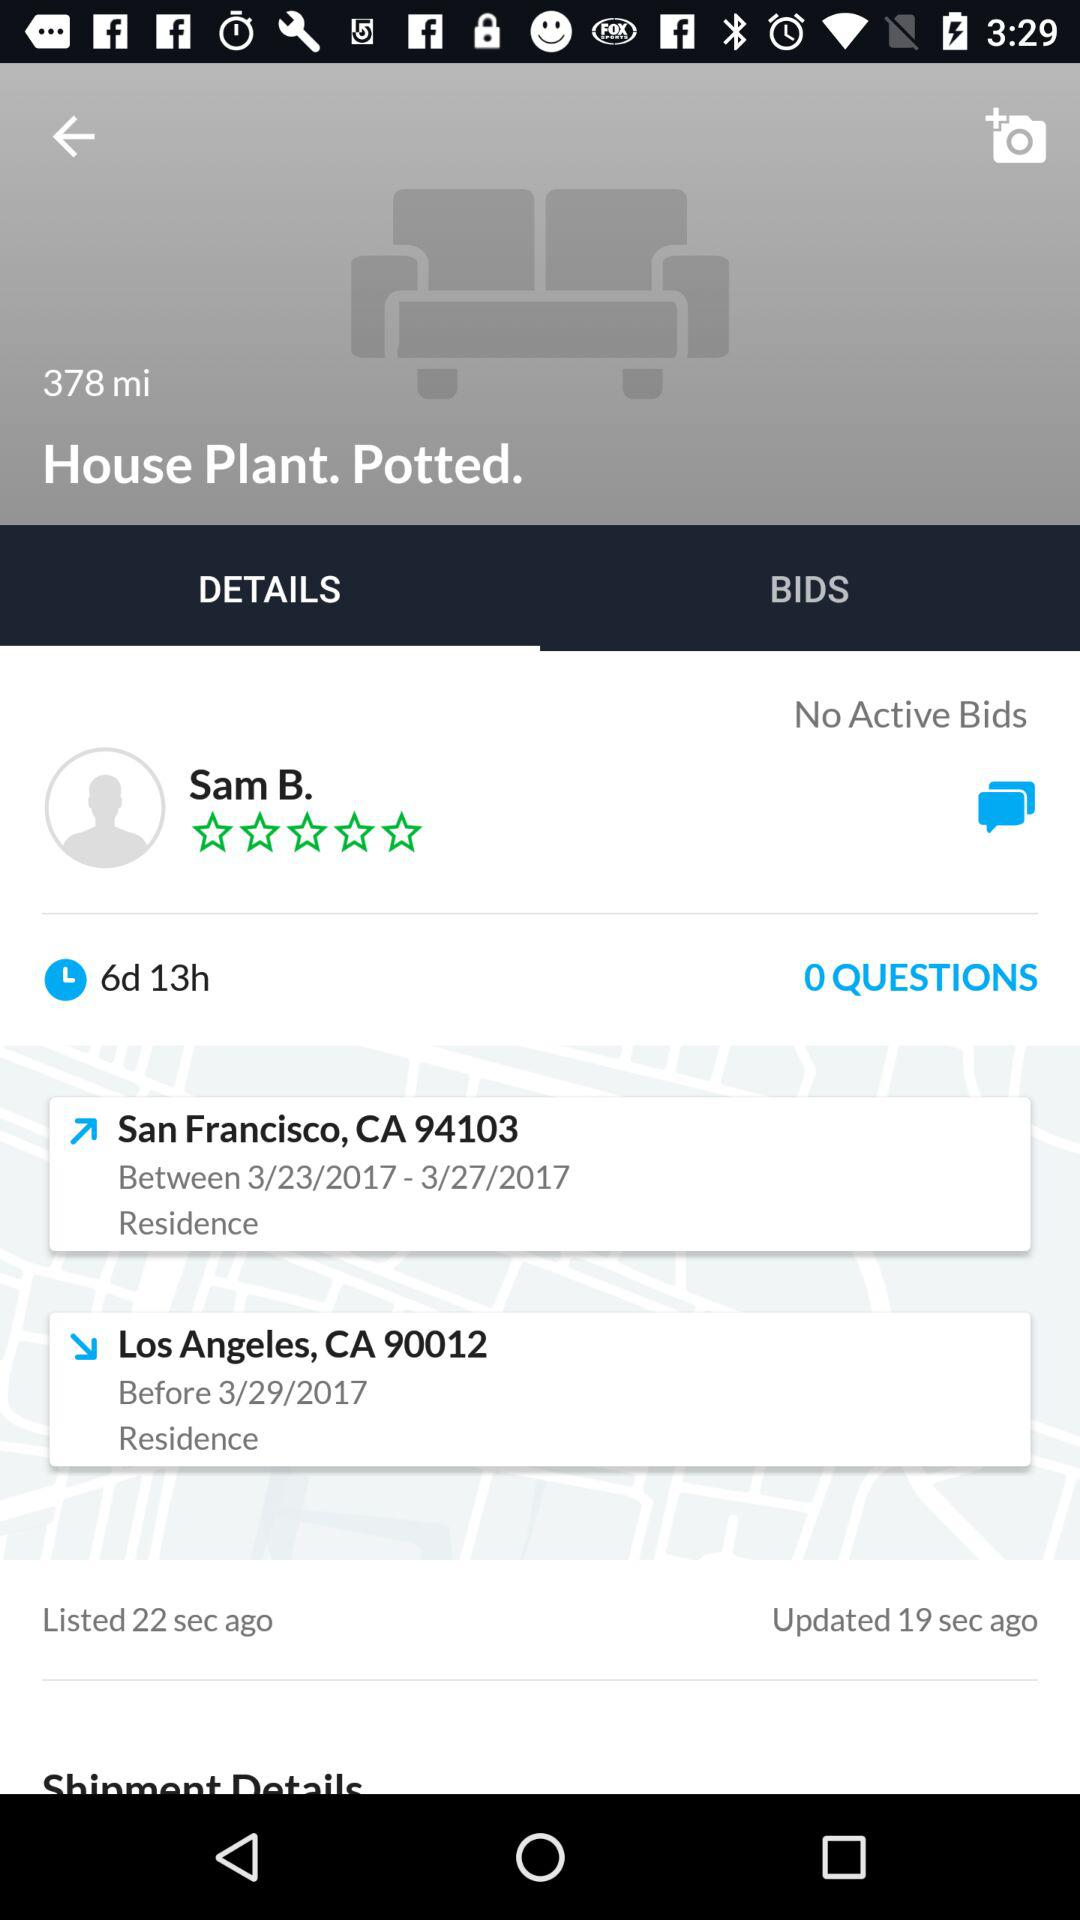How many bids are there on this item?
Answer the question using a single word or phrase. 0 